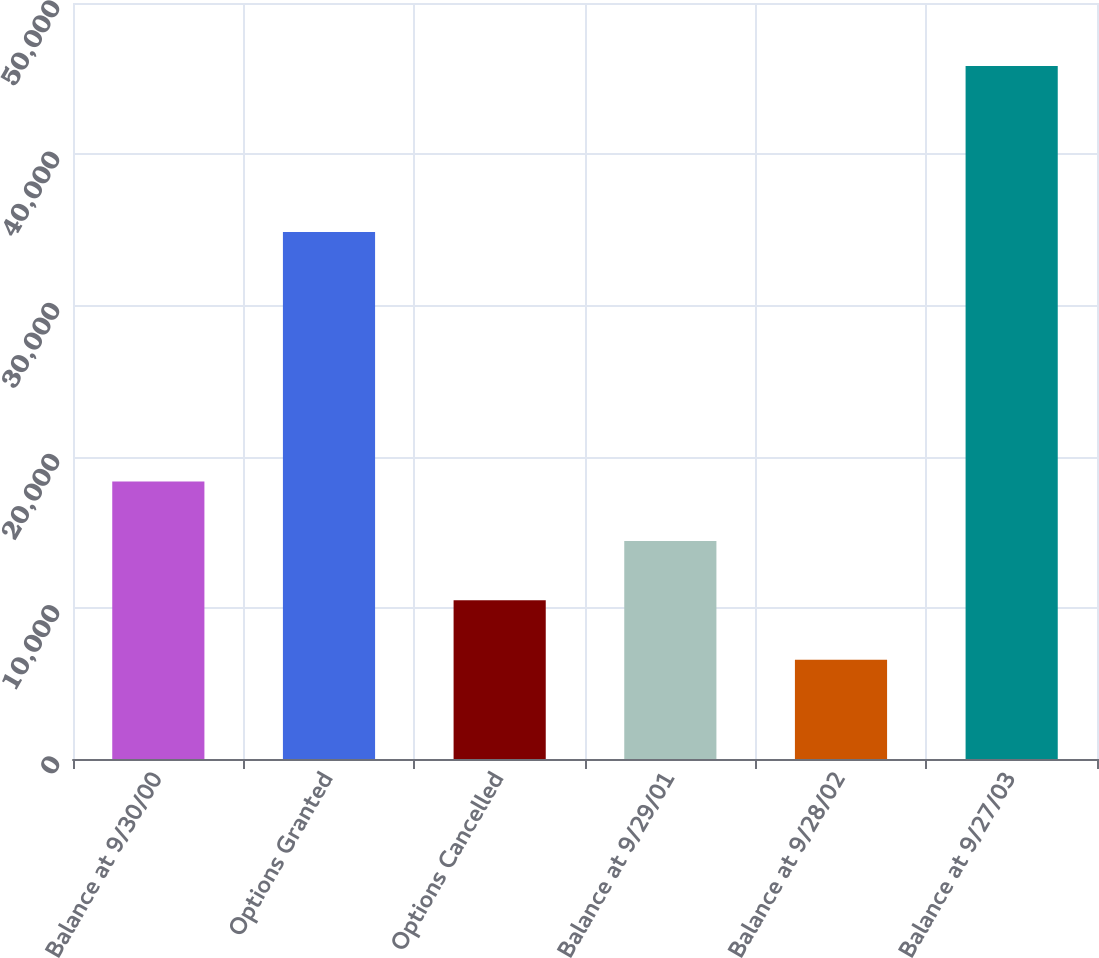<chart> <loc_0><loc_0><loc_500><loc_500><bar_chart><fcel>Balance at 9/30/00<fcel>Options Granted<fcel>Options Cancelled<fcel>Balance at 9/29/01<fcel>Balance at 9/28/02<fcel>Balance at 9/27/03<nl><fcel>18348.7<fcel>34857<fcel>10496.9<fcel>14422.8<fcel>6571<fcel>45830<nl></chart> 